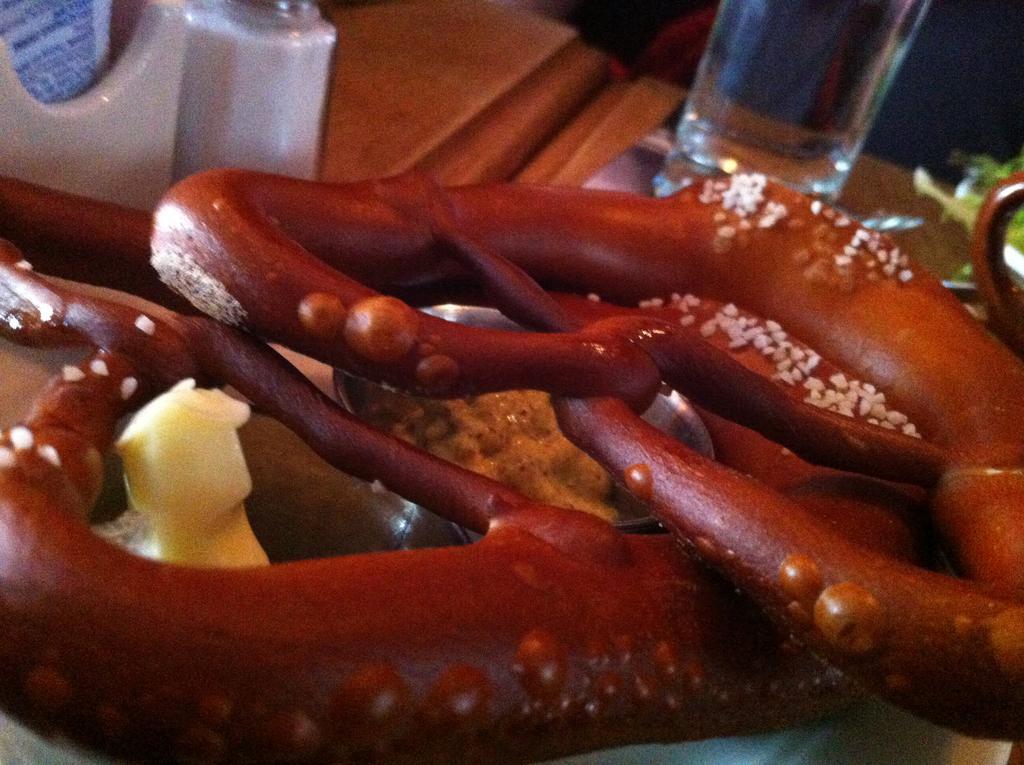In one or two sentences, can you explain what this image depicts? Here in this picture we can see some food item present on a plate, which is present on the table over there and we can also see a glass of water present and some other things present on he table over there. 